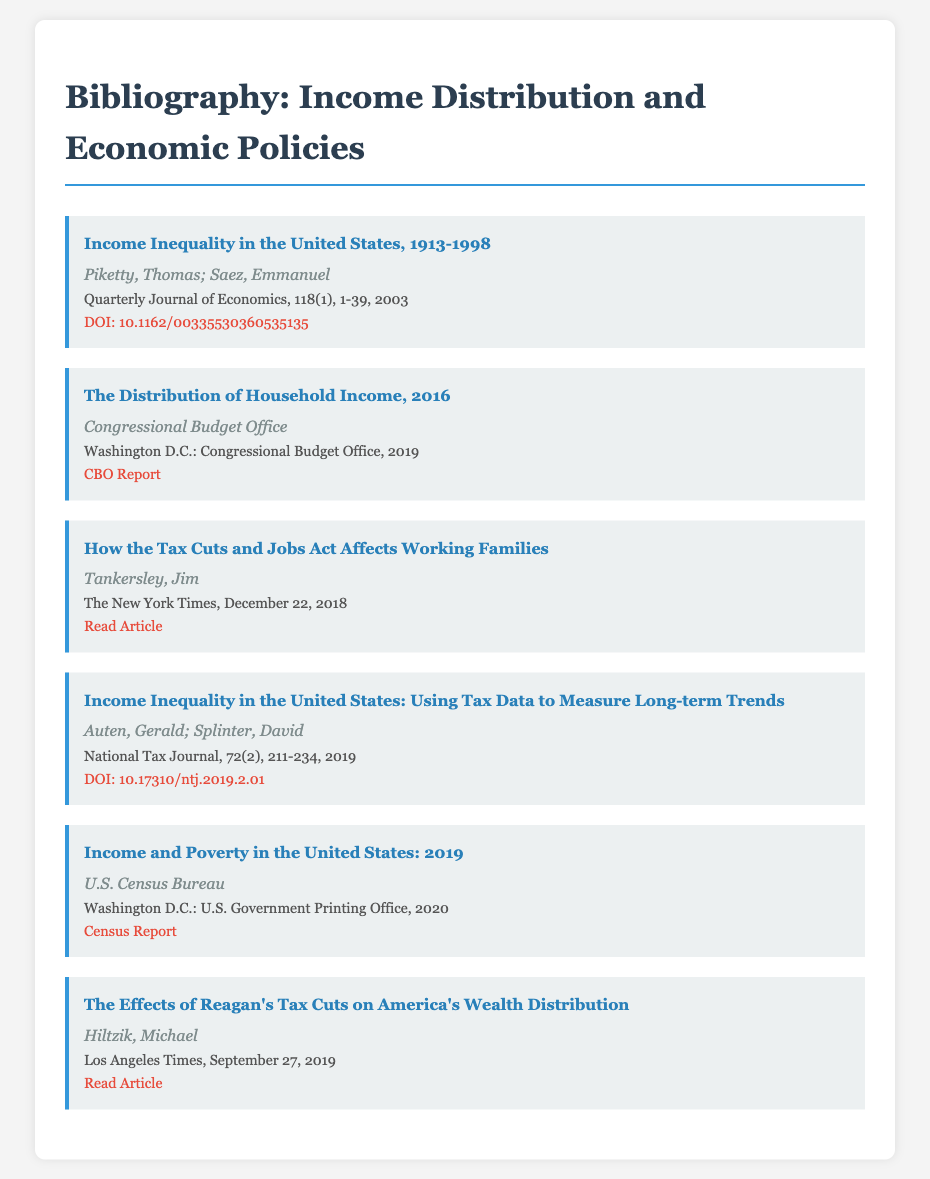What is the title of the first entry? The title of the first entry is "Income Inequality in the United States, 1913-1998."
Answer: Income Inequality in the United States, 1913-1998 Who are the authors of the second entry? The authors of the second entry are the Congressional Budget Office.
Answer: Congressional Budget Office What year was the report "Income and Poverty in the United States: 2019" published? The report "Income and Poverty in the United States: 2019" was published in 2020.
Answer: 2020 What is the main topic of the third entry? The main topic of the third entry is how the Tax Cuts and Jobs Act affects working families.
Answer: Tax Cuts and Jobs Act affects working families Which journal published the fourth entry? The fourth entry was published in the National Tax Journal.
Answer: National Tax Journal How many authors wrote the article "Income Inequality in the United States: Using Tax Data to Measure Long-term Trends"? Two authors wrote the article.
Answer: Two authors What type of document is the source of "The Effects of Reagan's Tax Cuts on America's Wealth Distribution"? The source is a news article.
Answer: News article What is the focus of the bibliography as a whole? The bibliography focuses on income distribution patterns before and after major policy changes.
Answer: Income distribution patterns before and after major policy changes 